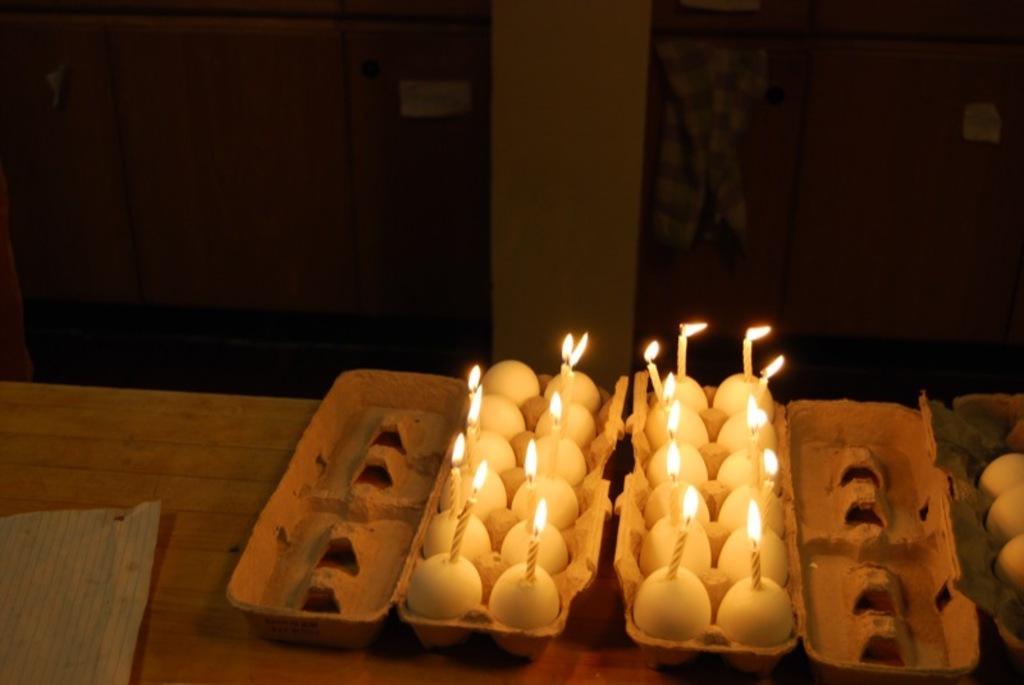How would you summarize this image in a sentence or two? On the table we can see boxes, eggs and candles. On the back we can see cloth near to the door. On the left we can see another door. Here we can see a pillar. 